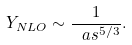Convert formula to latex. <formula><loc_0><loc_0><loc_500><loc_500>Y _ { N L O } \sim \frac { 1 } { \ a s ^ { 5 / 3 } } .</formula> 